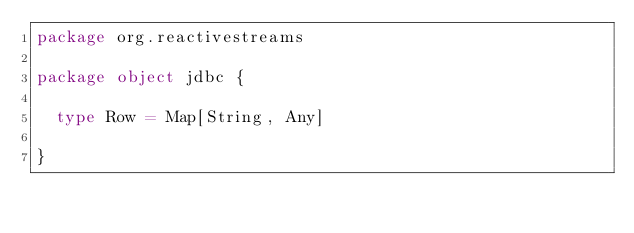Convert code to text. <code><loc_0><loc_0><loc_500><loc_500><_Scala_>package org.reactivestreams

package object jdbc {

  type Row = Map[String, Any]

}
</code> 